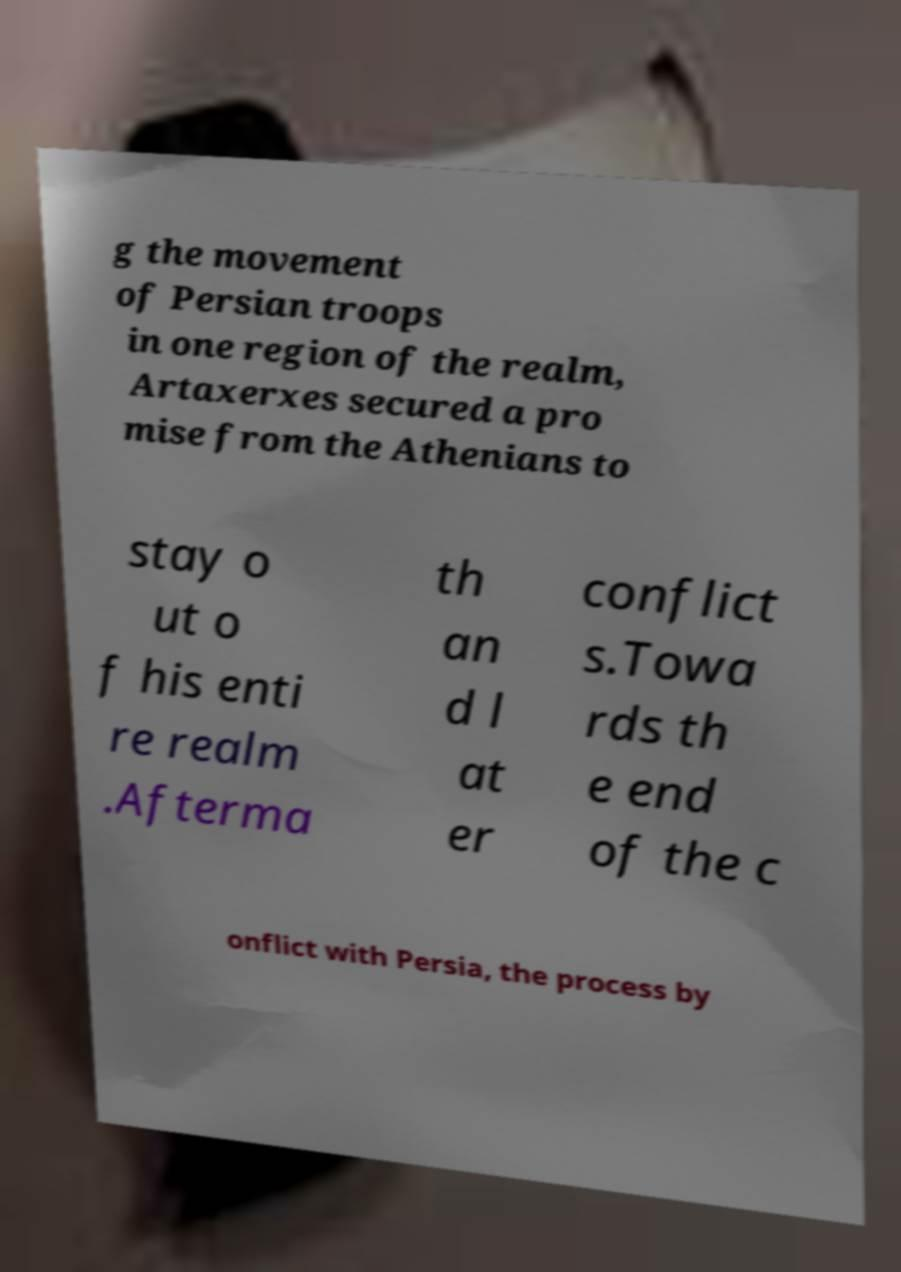I need the written content from this picture converted into text. Can you do that? g the movement of Persian troops in one region of the realm, Artaxerxes secured a pro mise from the Athenians to stay o ut o f his enti re realm .Afterma th an d l at er conflict s.Towa rds th e end of the c onflict with Persia, the process by 